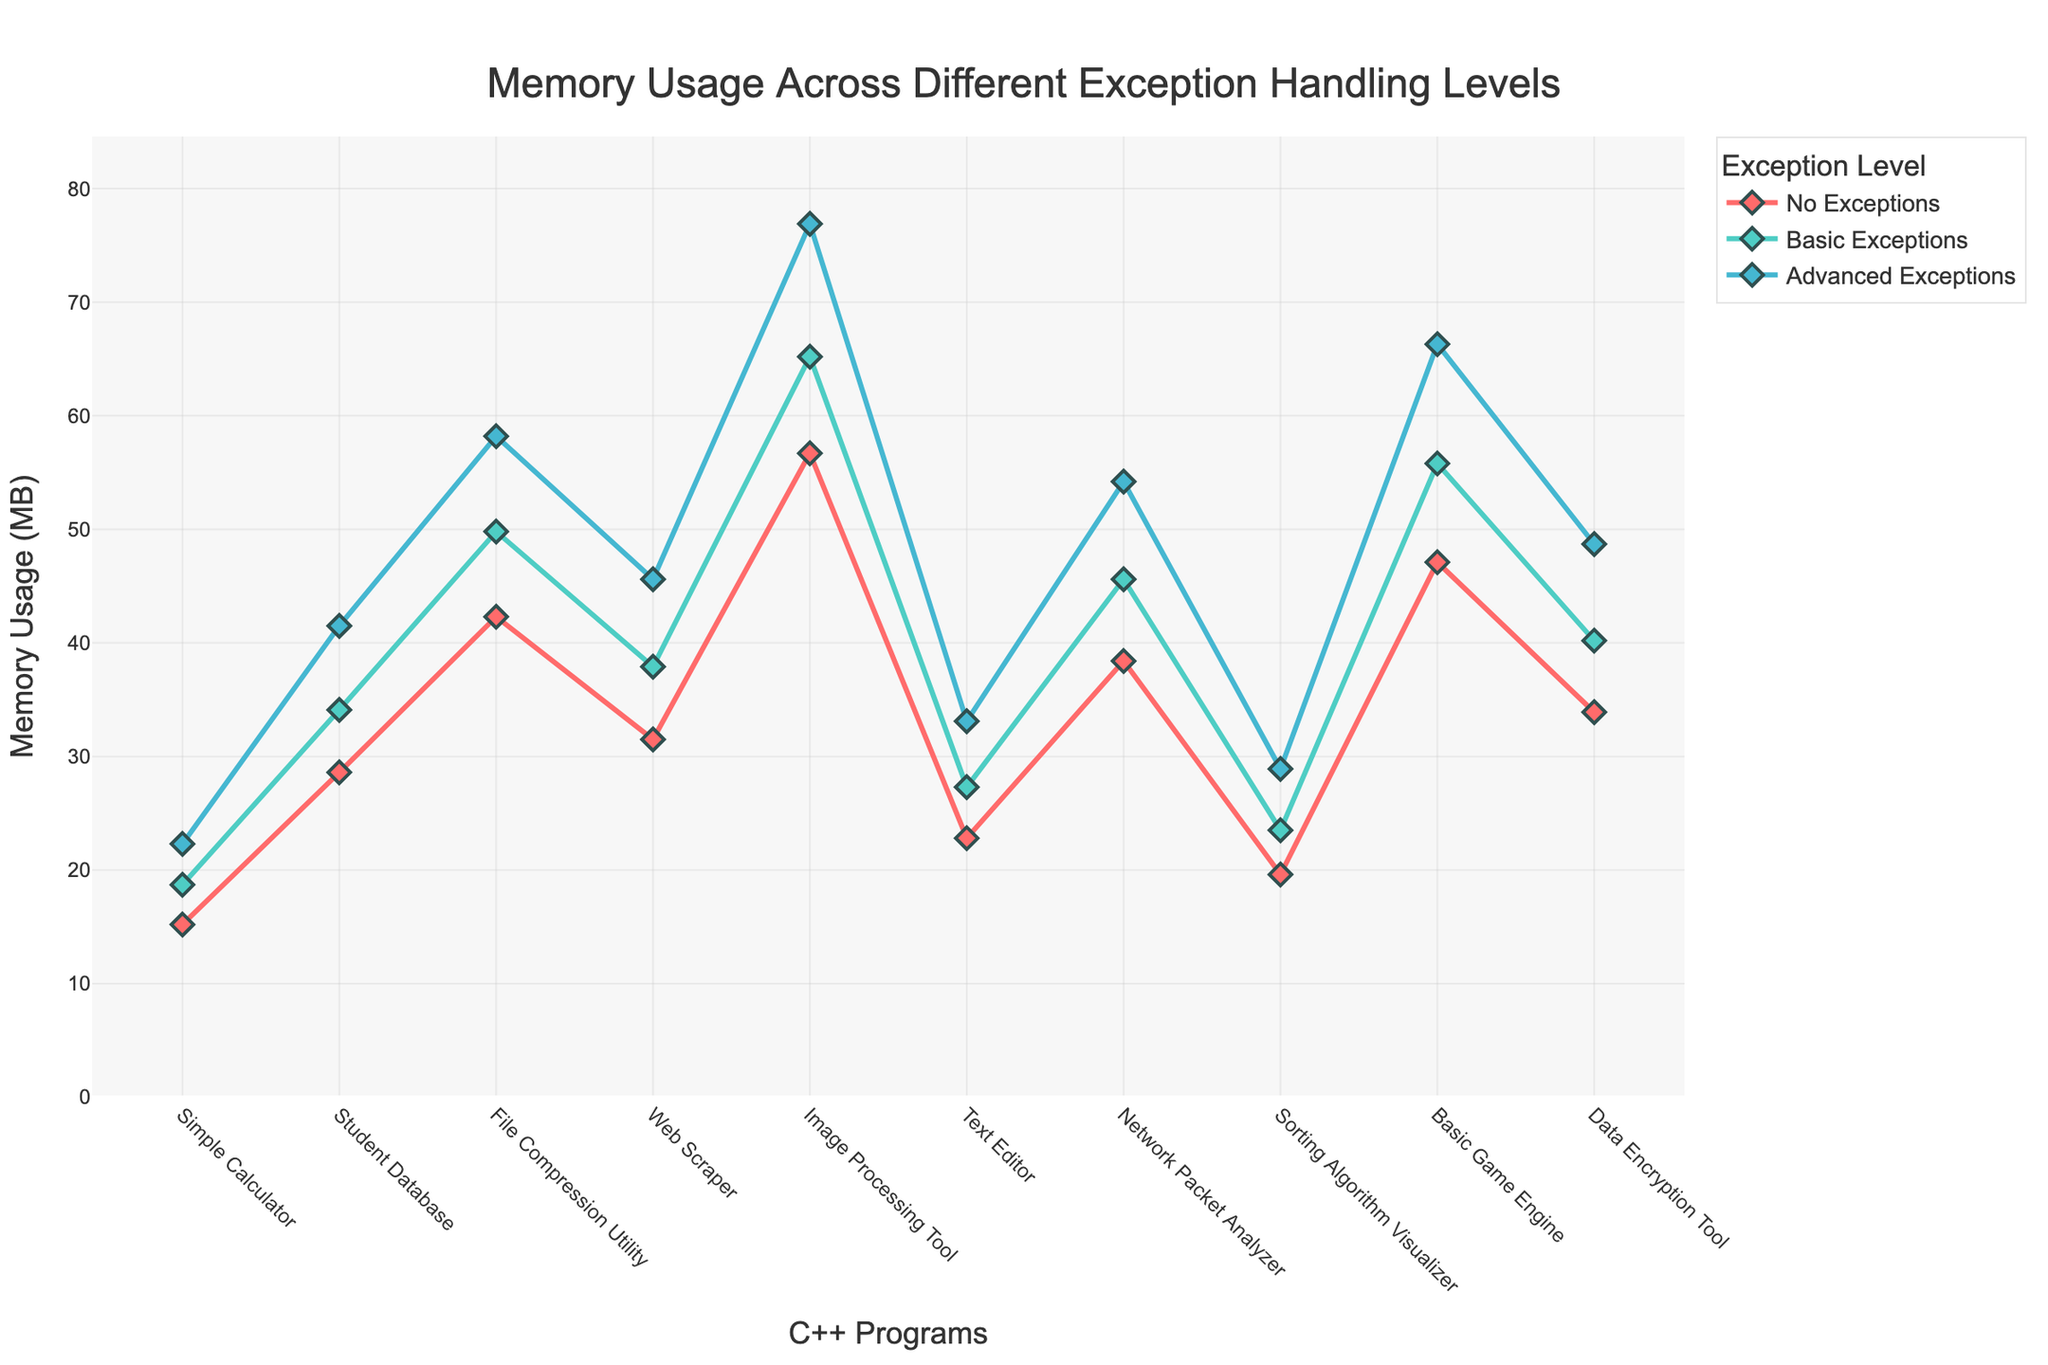What program exhibits the highest memory usage with Advanced Exceptions? By examining the line chart, you can identify which program's point is the highest on the y-axis for the "Advanced Exceptions" line.
Answer: Image Processing Tool How much does memory usage increase from No Exceptions to Basic Exceptions for the Web Scraper program? Look at the memory usage values for the Web Scraper under both "No Exceptions" and "Basic Exceptions," then subtract the former from the latter: 37.9 MB - 31.5 MB
Answer: 6.4 MB Which exception level has the lowest overall memory usage across all programs? Examine the different lines representing each exception level, and identify the one that consistently appears the lowest.
Answer: No Exceptions How does the memory usage difference between No Exceptions and Advanced Exceptions for the Text Editor compare to the Student Database? Calculate the difference for both:
- Text Editor: 33.1 MB - 22.8 MB = 10.3 MB
- Student Database: 41.5 MB - 28.6 MB = 12.9 MB. Then compare these differences.
Answer: Student Database has a greater difference What is the average memory usage for the Sorting Algorithm Visualizer across all exception levels? Sum the memory usage values at all exception levels for the Sorting Algorithm Visualizer (19.6 + 23.5 + 28.9), and then divide by the number of levels (3): (19.6 + 23.5 + 28.9) / 3
Answer: 24 MB Which program shows the largest relative increase in memory usage when moving from Basic Exceptions to Advanced Exceptions? Calculate the relative increase for each program using the formula: (Advanced - Basic) / Basic, and identify the largest:
- Simple Calculator: (22.3 - 18.7) / 18.7
- Student Database: (41.5 - 34.1) / 34.1
- File Compression Utility: (58.2 - 49.8) / 49.8
- etc.
Answer: Sorting Algorithm Visualizer (22.98%) In which program is the memory usage most similar between No Exceptions and Basic Exceptions? Calculate the absolute differences for each program between No Exceptions and Basic Exceptions and find the smallest difference:
- Simple Calculator: abs(18.7 - 15.2)
- Student Database: abs(34.1 - 28.6)
- etc.
Answer: Simple Calculator (3.5 MB) Which program has the steepest increase in memory usage with more advanced exception handling levels? Compare the slope of each program’s line as it progresses from "No Exceptions" to "Advanced Exceptions."
Answer: Image Processing Tool (from 56.7 to 76.9 MB) Which exceptions level shows the greatest variation in memory usage across different programs? Assess the "spread" of y-values in the line chart for each exception level. The line with the greatest vertical distance between the highest and lowest points indicates the most variation.
Answer: Advanced Exceptions What's the total memory usage for all programs with Basic Exceptions? Add the memory usage values for all programs under "Basic Exceptions":
18.7 + 34.1 + 49.8 + 37.9 + 65.2 + 27.3 + 45.6 + 23.5 + 55.8 + 40.2
Answer: 398.1 MB 